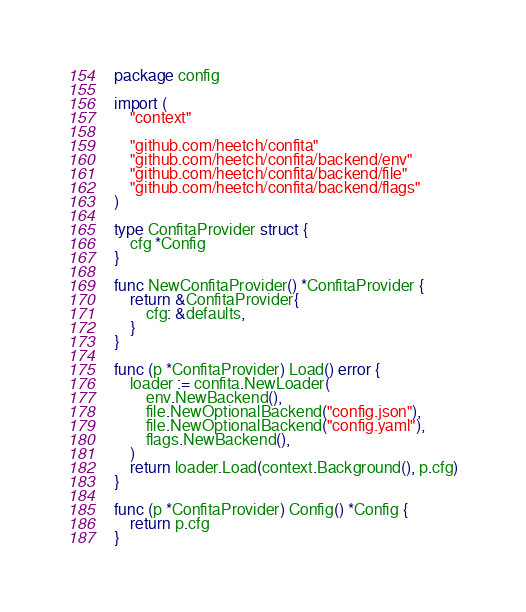Convert code to text. <code><loc_0><loc_0><loc_500><loc_500><_Go_>package config

import (
	"context"

	"github.com/heetch/confita"
	"github.com/heetch/confita/backend/env"
	"github.com/heetch/confita/backend/file"
	"github.com/heetch/confita/backend/flags"
)

type ConfitaProvider struct {
	cfg *Config
}

func NewConfitaProvider() *ConfitaProvider {
	return &ConfitaProvider{
		cfg: &defaults,
	}
}

func (p *ConfitaProvider) Load() error {
	loader := confita.NewLoader(
		env.NewBackend(),
		file.NewOptionalBackend("config.json"),
		file.NewOptionalBackend("config.yaml"),
		flags.NewBackend(),
	)
	return loader.Load(context.Background(), p.cfg)
}

func (p *ConfitaProvider) Config() *Config {
	return p.cfg
}
</code> 